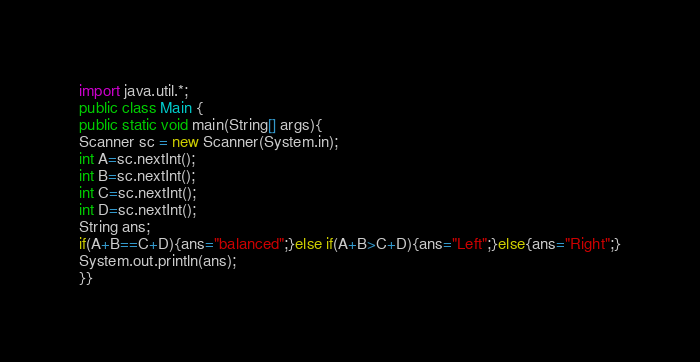<code> <loc_0><loc_0><loc_500><loc_500><_Java_>import java.util.*;
public class Main {
public static void main(String[] args){
Scanner sc = new Scanner(System.in);
int A=sc.nextInt();
int B=sc.nextInt();
int C=sc.nextInt();
int D=sc.nextInt();
String ans;
if(A+B==C+D){ans="balanced";}else if(A+B>C+D){ans="Left";}else{ans="Right";}
System.out.println(ans);
}}</code> 